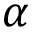<formula> <loc_0><loc_0><loc_500><loc_500>\alpha</formula> 